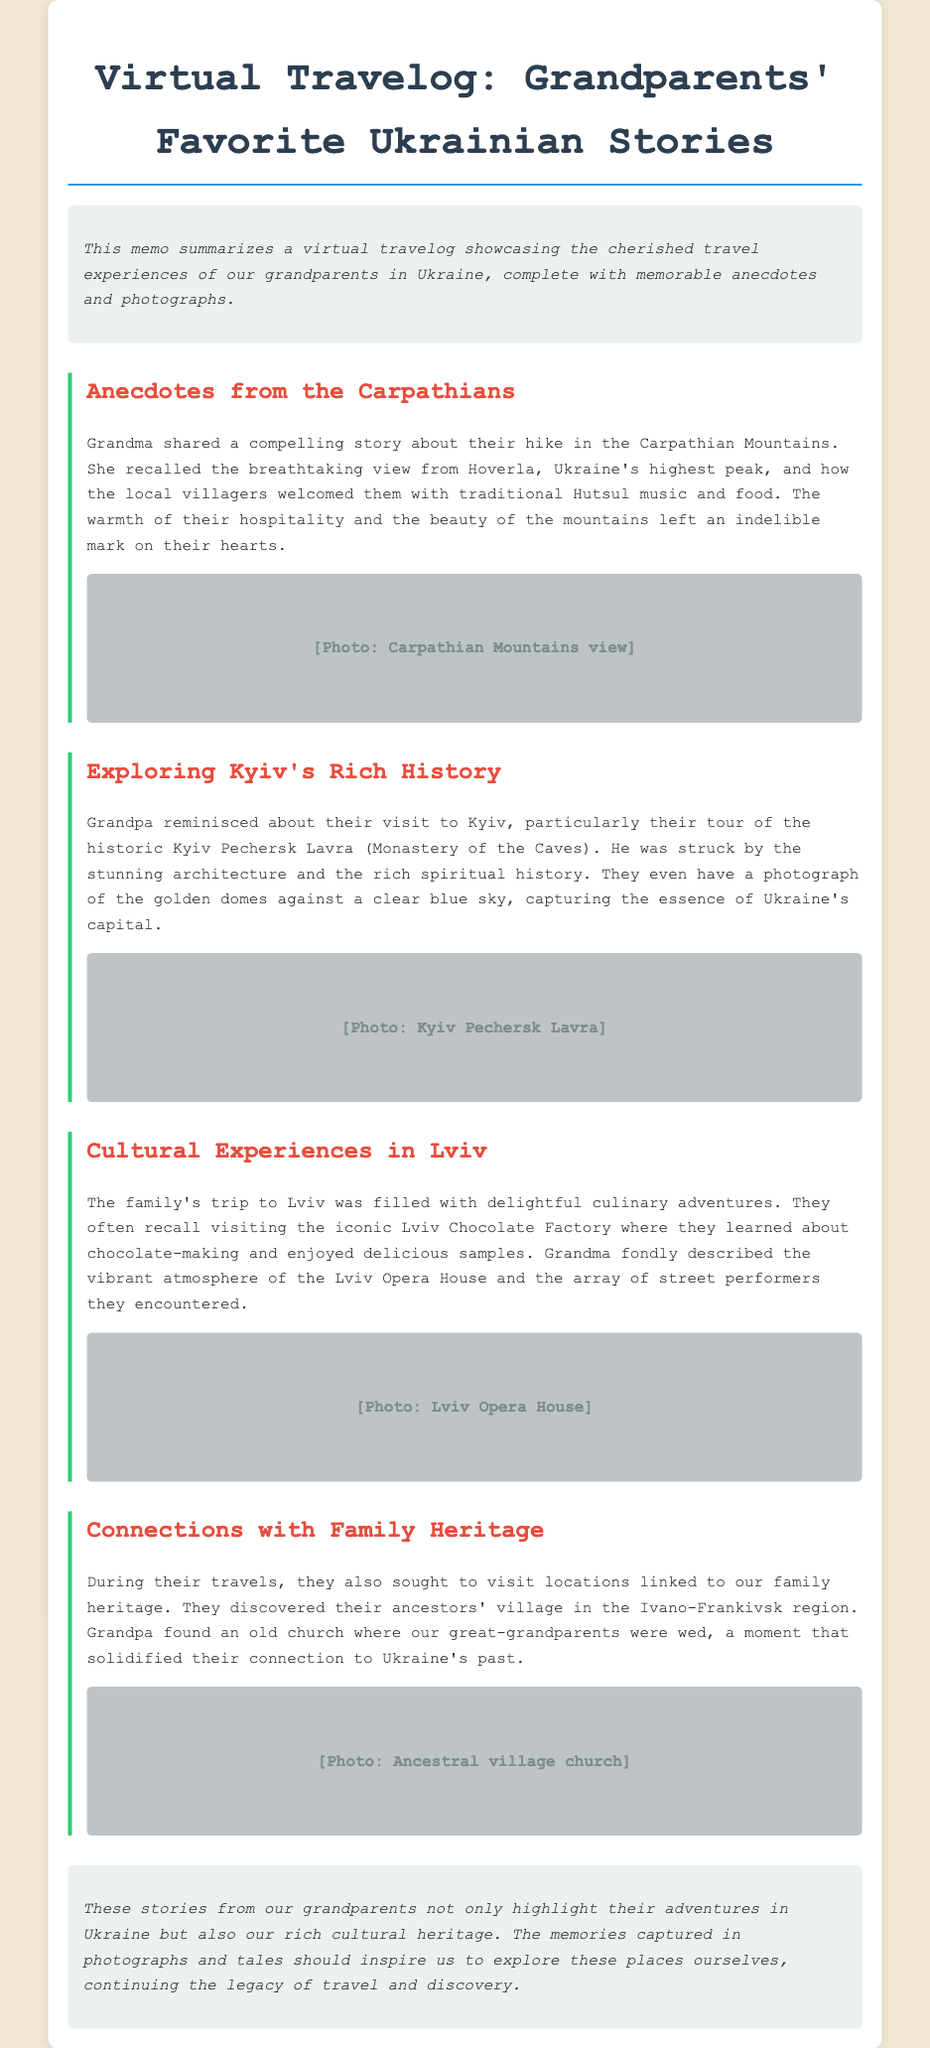What is the title of the document? The title of the document is the main heading presented at the top.
Answer: Virtual Travelog: Grandparents' Favorite Ukrainian Stories Which mountain did Grandma hike? The document mentions a specific peak that Grandma hiked during her travels.
Answer: Hoverla What is the significant historical site in Kyiv mentioned by Grandpa? The document identifies a notable place that Grandpa visited in Kyiv that has a rich history.
Answer: Kyiv Pechersk Lavra What unique culinary location did the family visit in Lviv? The document highlights a specific place where the family enjoyed a culinary experience.
Answer: Lviv Chocolate Factory What did Grandpa find in the Ivano-Frankivsk region? The document describes a discovery made by Grandpa while exploring family heritage connections.
Answer: An old church How did the villagers greet Grandma and Grandpa in the Carpathians? The document includes a detail about the locals' welcome during their hiking experience.
Answer: Traditional Hutsul music and food What atmosphere does Grandma describe at the Lviv Opera House? The document conveys a specific feeling or ambiance associated with the Lviv Opera House visit.
Answer: Vibrant What should the stories from grandparents inspire us to do? The concluding statement emphasizes a particular action or legacy inspired by the stories.
Answer: Explore these places ourselves 